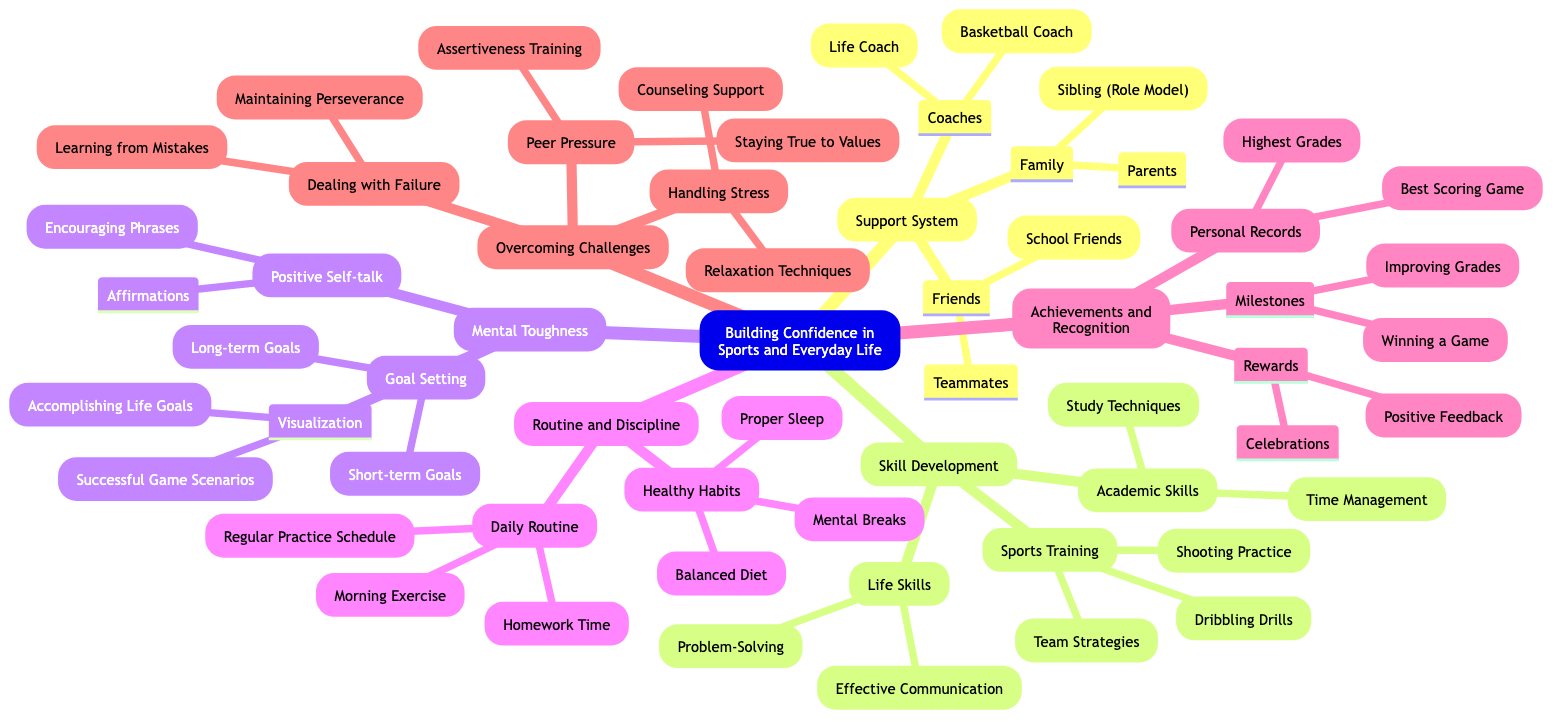What is one element under the Support System? The diagram lists several elements under the Support System, including Family, Friends, and Coaches. One specific element from Family is Parents.
Answer: Parents How many components are in the Mental Toughness section? The Mental Toughness section has three main components: Positive Self-talk, Goal Setting, and Visualization. Therefore, the count is three.
Answer: 3 Which skill is categorized under Life Skills in Skill Development? The Life Skills category includes Effective Communication and Problem-Solving. One example is Effective Communication.
Answer: Effective Communication What type of daily activity is listed under Routine and Discipline? The Routine and Discipline section includes Daily Routine and Healthy Habits. One specific activity in Daily Routine is Morning Exercise.
Answer: Morning Exercise How does overcoming challenges relate to peer pressure? The Overcoming Challenges section specifically lists Peer Pressure as one of the challenges faced, emphasizing the relationship between them.
Answer: Peer Pressure What are the rewards mentioned under Achievements and Recognition? In the Achievements and Recognition section, two types of rewards are listed: Celebrations and Positive Feedback, indicating the forms of recognition for achievements.
Answer: Celebrations How many sub-elements are there under Sports Training? Under the Skill Development category, Sports Training lists three sub-elements: Dribbling Drills, Shooting Practice, and Team Strategies, making the total count three.
Answer: 3 What is a relaxation technique listed under Handling Stress? The Handling Stress portion in Overcoming Challenges states Relaxation Techniques as an approach to manage stress effectively.
Answer: Relaxation Techniques What are the types of goals in the Goal Setting component? The Goal Setting section in Mental Toughness includes two types of goals: Short-term Goals and Long-term Goals, showcasing the different timelines for goal achievement.
Answer: Short-term Goals, Long-term Goals 